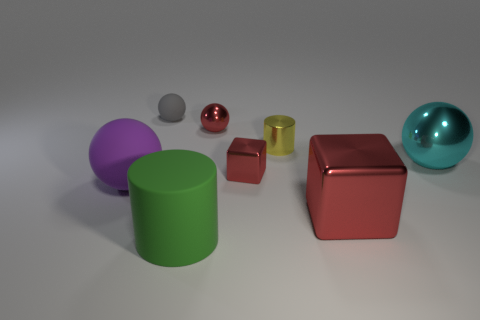What number of purple balls are made of the same material as the green thing?
Make the answer very short. 1. Is the number of big purple matte things less than the number of matte spheres?
Keep it short and to the point. Yes. Is the cylinder that is in front of the big cyan metallic ball made of the same material as the red ball?
Offer a terse response. No. What number of cylinders are either large green rubber objects or red things?
Provide a short and direct response. 1. What shape is the object that is behind the purple sphere and to the right of the yellow metallic object?
Ensure brevity in your answer.  Sphere. There is a ball behind the small ball that is in front of the small object behind the small red ball; what is its color?
Provide a succinct answer. Gray. Are there fewer large metal things left of the big metal ball than yellow shiny objects?
Your response must be concise. No. There is a tiny object on the left side of the large green rubber thing; is its shape the same as the small yellow thing that is to the right of the tiny red metal block?
Offer a very short reply. No. What number of things are spheres on the right side of the gray sphere or big cyan balls?
Your response must be concise. 2. What is the material of the small block that is the same color as the large cube?
Ensure brevity in your answer.  Metal. 